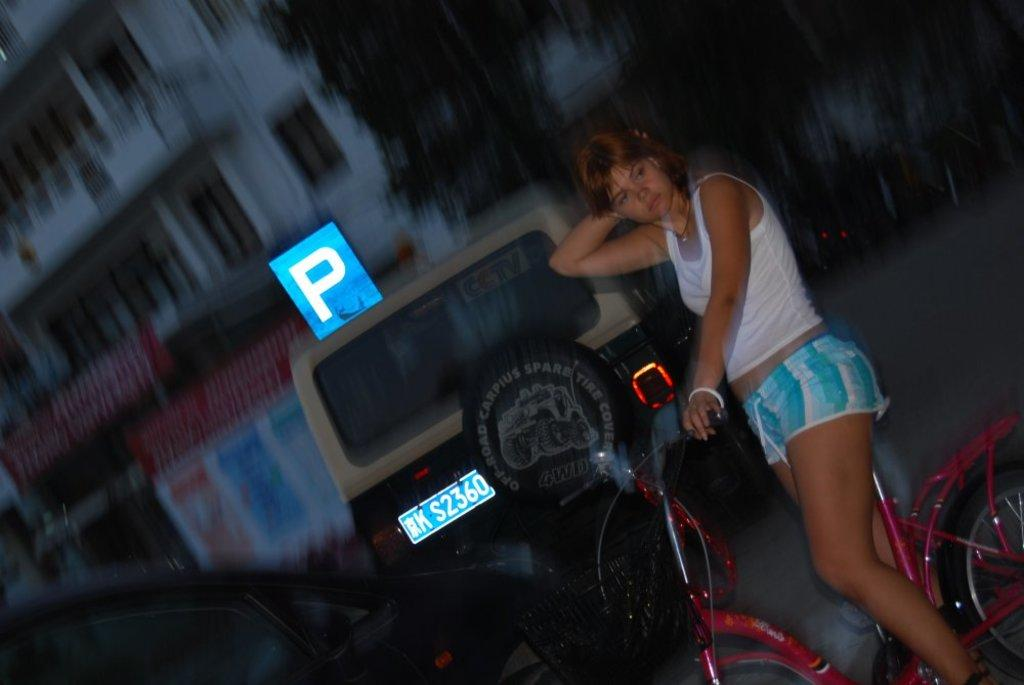Who is the main subject in the image? There is a woman in the image. What is the woman doing in the image? The woman is on a cycle. What can be seen in the background of the image? There are vehicles, trees, and a building in the background of the image. How many men are present in the image? There are no men present in the image; it features a woman on a cycle. What type of cup is being used to increase the speed of the cycle? There is no cup present in the image, and the speed of the cycle is not being increased by any means shown. 